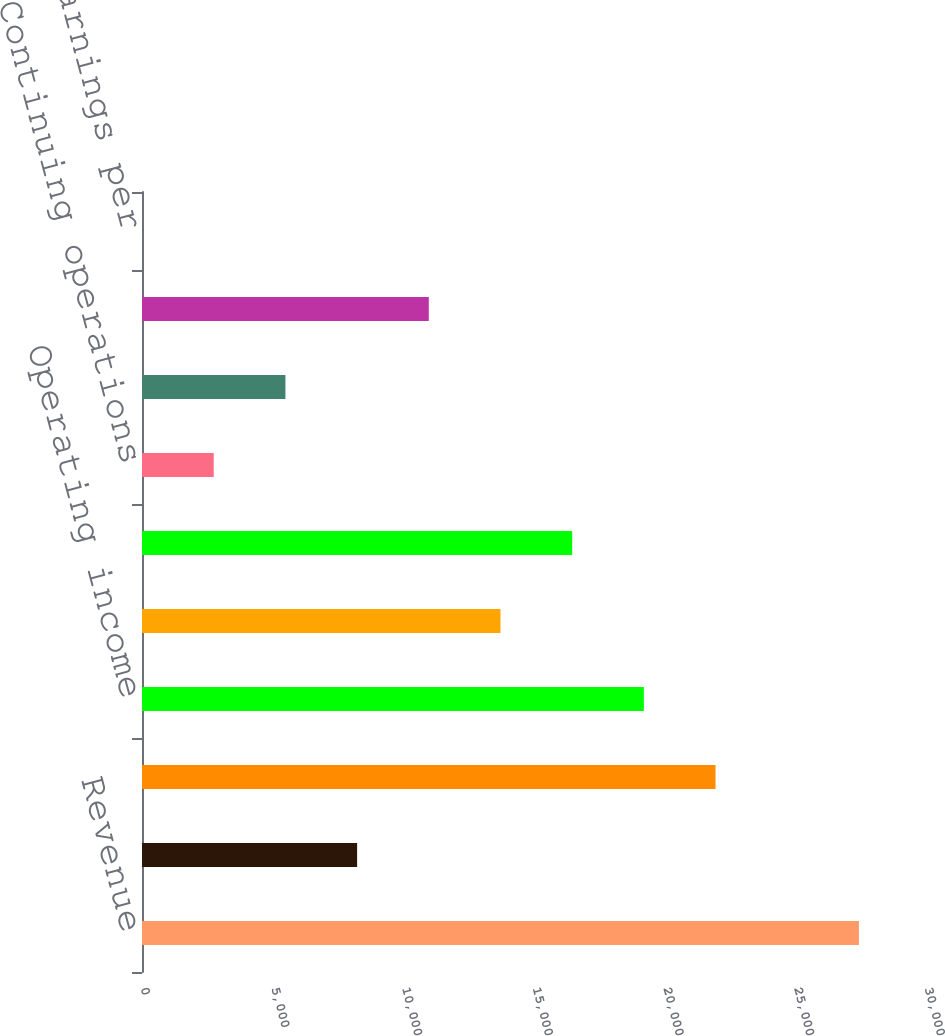Convert chart to OTSL. <chart><loc_0><loc_0><loc_500><loc_500><bar_chart><fcel>Revenue<fcel>Comparable store sales change<fcel>Gross profit<fcel>Operating income<fcel>Earnings from continuing<fcel>Net earnings<fcel>Continuing operations<fcel>Diluted earnings per share<fcel>Net (loss) earnings<fcel>Diluted (loss) earnings per<nl><fcel>27433<fcel>8231.4<fcel>21946.8<fcel>19203.8<fcel>13717.6<fcel>16460.7<fcel>2745.22<fcel>5488.31<fcel>10974.5<fcel>2.13<nl></chart> 